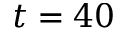<formula> <loc_0><loc_0><loc_500><loc_500>t = 4 0</formula> 